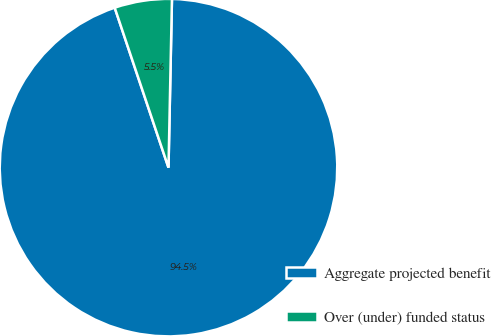Convert chart to OTSL. <chart><loc_0><loc_0><loc_500><loc_500><pie_chart><fcel>Aggregate projected benefit<fcel>Over (under) funded status<nl><fcel>94.51%<fcel>5.49%<nl></chart> 